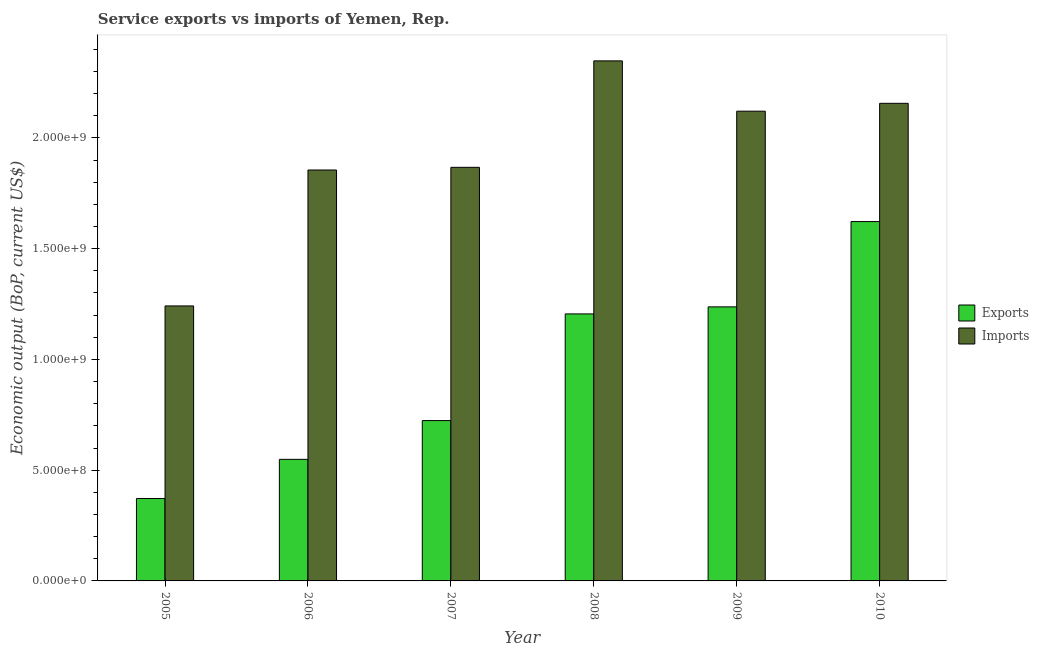How many different coloured bars are there?
Provide a short and direct response. 2. How many groups of bars are there?
Give a very brief answer. 6. What is the label of the 6th group of bars from the left?
Give a very brief answer. 2010. What is the amount of service imports in 2010?
Keep it short and to the point. 2.16e+09. Across all years, what is the maximum amount of service exports?
Make the answer very short. 1.62e+09. Across all years, what is the minimum amount of service imports?
Your response must be concise. 1.24e+09. In which year was the amount of service exports maximum?
Give a very brief answer. 2010. What is the total amount of service imports in the graph?
Give a very brief answer. 1.16e+1. What is the difference between the amount of service imports in 2005 and that in 2006?
Make the answer very short. -6.14e+08. What is the difference between the amount of service exports in 2005 and the amount of service imports in 2007?
Keep it short and to the point. -3.52e+08. What is the average amount of service imports per year?
Offer a very short reply. 1.93e+09. What is the ratio of the amount of service imports in 2005 to that in 2006?
Ensure brevity in your answer.  0.67. Is the amount of service exports in 2005 less than that in 2009?
Provide a short and direct response. Yes. What is the difference between the highest and the second highest amount of service exports?
Give a very brief answer. 3.85e+08. What is the difference between the highest and the lowest amount of service exports?
Keep it short and to the point. 1.25e+09. What does the 1st bar from the left in 2005 represents?
Give a very brief answer. Exports. What does the 1st bar from the right in 2006 represents?
Your response must be concise. Imports. How many years are there in the graph?
Your answer should be very brief. 6. What is the difference between two consecutive major ticks on the Y-axis?
Keep it short and to the point. 5.00e+08. Does the graph contain grids?
Give a very brief answer. No. How many legend labels are there?
Keep it short and to the point. 2. How are the legend labels stacked?
Make the answer very short. Vertical. What is the title of the graph?
Offer a terse response. Service exports vs imports of Yemen, Rep. Does "Foreign Liabilities" appear as one of the legend labels in the graph?
Ensure brevity in your answer.  No. What is the label or title of the X-axis?
Your answer should be very brief. Year. What is the label or title of the Y-axis?
Keep it short and to the point. Economic output (BoP, current US$). What is the Economic output (BoP, current US$) in Exports in 2005?
Provide a short and direct response. 3.72e+08. What is the Economic output (BoP, current US$) of Imports in 2005?
Keep it short and to the point. 1.24e+09. What is the Economic output (BoP, current US$) of Exports in 2006?
Your answer should be very brief. 5.49e+08. What is the Economic output (BoP, current US$) in Imports in 2006?
Provide a short and direct response. 1.86e+09. What is the Economic output (BoP, current US$) of Exports in 2007?
Give a very brief answer. 7.24e+08. What is the Economic output (BoP, current US$) of Imports in 2007?
Ensure brevity in your answer.  1.87e+09. What is the Economic output (BoP, current US$) of Exports in 2008?
Keep it short and to the point. 1.21e+09. What is the Economic output (BoP, current US$) of Imports in 2008?
Provide a succinct answer. 2.35e+09. What is the Economic output (BoP, current US$) in Exports in 2009?
Your answer should be compact. 1.24e+09. What is the Economic output (BoP, current US$) in Imports in 2009?
Offer a terse response. 2.12e+09. What is the Economic output (BoP, current US$) of Exports in 2010?
Your response must be concise. 1.62e+09. What is the Economic output (BoP, current US$) in Imports in 2010?
Keep it short and to the point. 2.16e+09. Across all years, what is the maximum Economic output (BoP, current US$) in Exports?
Ensure brevity in your answer.  1.62e+09. Across all years, what is the maximum Economic output (BoP, current US$) of Imports?
Ensure brevity in your answer.  2.35e+09. Across all years, what is the minimum Economic output (BoP, current US$) of Exports?
Offer a terse response. 3.72e+08. Across all years, what is the minimum Economic output (BoP, current US$) in Imports?
Provide a succinct answer. 1.24e+09. What is the total Economic output (BoP, current US$) in Exports in the graph?
Offer a terse response. 5.71e+09. What is the total Economic output (BoP, current US$) in Imports in the graph?
Your response must be concise. 1.16e+1. What is the difference between the Economic output (BoP, current US$) in Exports in 2005 and that in 2006?
Your response must be concise. -1.77e+08. What is the difference between the Economic output (BoP, current US$) of Imports in 2005 and that in 2006?
Offer a very short reply. -6.14e+08. What is the difference between the Economic output (BoP, current US$) in Exports in 2005 and that in 2007?
Offer a terse response. -3.52e+08. What is the difference between the Economic output (BoP, current US$) in Imports in 2005 and that in 2007?
Your answer should be compact. -6.26e+08. What is the difference between the Economic output (BoP, current US$) of Exports in 2005 and that in 2008?
Give a very brief answer. -8.33e+08. What is the difference between the Economic output (BoP, current US$) of Imports in 2005 and that in 2008?
Offer a very short reply. -1.11e+09. What is the difference between the Economic output (BoP, current US$) of Exports in 2005 and that in 2009?
Ensure brevity in your answer.  -8.65e+08. What is the difference between the Economic output (BoP, current US$) of Imports in 2005 and that in 2009?
Provide a short and direct response. -8.79e+08. What is the difference between the Economic output (BoP, current US$) in Exports in 2005 and that in 2010?
Keep it short and to the point. -1.25e+09. What is the difference between the Economic output (BoP, current US$) of Imports in 2005 and that in 2010?
Your answer should be compact. -9.15e+08. What is the difference between the Economic output (BoP, current US$) of Exports in 2006 and that in 2007?
Your response must be concise. -1.75e+08. What is the difference between the Economic output (BoP, current US$) in Imports in 2006 and that in 2007?
Offer a very short reply. -1.21e+07. What is the difference between the Economic output (BoP, current US$) in Exports in 2006 and that in 2008?
Ensure brevity in your answer.  -6.57e+08. What is the difference between the Economic output (BoP, current US$) in Imports in 2006 and that in 2008?
Your response must be concise. -4.93e+08. What is the difference between the Economic output (BoP, current US$) of Exports in 2006 and that in 2009?
Provide a succinct answer. -6.88e+08. What is the difference between the Economic output (BoP, current US$) of Imports in 2006 and that in 2009?
Your answer should be very brief. -2.66e+08. What is the difference between the Economic output (BoP, current US$) in Exports in 2006 and that in 2010?
Provide a succinct answer. -1.07e+09. What is the difference between the Economic output (BoP, current US$) of Imports in 2006 and that in 2010?
Your answer should be compact. -3.01e+08. What is the difference between the Economic output (BoP, current US$) of Exports in 2007 and that in 2008?
Your answer should be very brief. -4.82e+08. What is the difference between the Economic output (BoP, current US$) in Imports in 2007 and that in 2008?
Provide a succinct answer. -4.81e+08. What is the difference between the Economic output (BoP, current US$) in Exports in 2007 and that in 2009?
Offer a very short reply. -5.13e+08. What is the difference between the Economic output (BoP, current US$) of Imports in 2007 and that in 2009?
Ensure brevity in your answer.  -2.53e+08. What is the difference between the Economic output (BoP, current US$) of Exports in 2007 and that in 2010?
Your response must be concise. -8.98e+08. What is the difference between the Economic output (BoP, current US$) of Imports in 2007 and that in 2010?
Offer a terse response. -2.89e+08. What is the difference between the Economic output (BoP, current US$) of Exports in 2008 and that in 2009?
Give a very brief answer. -3.18e+07. What is the difference between the Economic output (BoP, current US$) of Imports in 2008 and that in 2009?
Provide a short and direct response. 2.27e+08. What is the difference between the Economic output (BoP, current US$) in Exports in 2008 and that in 2010?
Provide a short and direct response. -4.17e+08. What is the difference between the Economic output (BoP, current US$) in Imports in 2008 and that in 2010?
Provide a succinct answer. 1.92e+08. What is the difference between the Economic output (BoP, current US$) in Exports in 2009 and that in 2010?
Provide a succinct answer. -3.85e+08. What is the difference between the Economic output (BoP, current US$) in Imports in 2009 and that in 2010?
Your response must be concise. -3.55e+07. What is the difference between the Economic output (BoP, current US$) of Exports in 2005 and the Economic output (BoP, current US$) of Imports in 2006?
Provide a succinct answer. -1.48e+09. What is the difference between the Economic output (BoP, current US$) in Exports in 2005 and the Economic output (BoP, current US$) in Imports in 2007?
Give a very brief answer. -1.50e+09. What is the difference between the Economic output (BoP, current US$) in Exports in 2005 and the Economic output (BoP, current US$) in Imports in 2008?
Provide a succinct answer. -1.98e+09. What is the difference between the Economic output (BoP, current US$) of Exports in 2005 and the Economic output (BoP, current US$) of Imports in 2009?
Make the answer very short. -1.75e+09. What is the difference between the Economic output (BoP, current US$) in Exports in 2005 and the Economic output (BoP, current US$) in Imports in 2010?
Your response must be concise. -1.78e+09. What is the difference between the Economic output (BoP, current US$) in Exports in 2006 and the Economic output (BoP, current US$) in Imports in 2007?
Your answer should be very brief. -1.32e+09. What is the difference between the Economic output (BoP, current US$) of Exports in 2006 and the Economic output (BoP, current US$) of Imports in 2008?
Your response must be concise. -1.80e+09. What is the difference between the Economic output (BoP, current US$) of Exports in 2006 and the Economic output (BoP, current US$) of Imports in 2009?
Ensure brevity in your answer.  -1.57e+09. What is the difference between the Economic output (BoP, current US$) of Exports in 2006 and the Economic output (BoP, current US$) of Imports in 2010?
Provide a succinct answer. -1.61e+09. What is the difference between the Economic output (BoP, current US$) in Exports in 2007 and the Economic output (BoP, current US$) in Imports in 2008?
Keep it short and to the point. -1.62e+09. What is the difference between the Economic output (BoP, current US$) in Exports in 2007 and the Economic output (BoP, current US$) in Imports in 2009?
Keep it short and to the point. -1.40e+09. What is the difference between the Economic output (BoP, current US$) in Exports in 2007 and the Economic output (BoP, current US$) in Imports in 2010?
Offer a terse response. -1.43e+09. What is the difference between the Economic output (BoP, current US$) in Exports in 2008 and the Economic output (BoP, current US$) in Imports in 2009?
Provide a succinct answer. -9.15e+08. What is the difference between the Economic output (BoP, current US$) of Exports in 2008 and the Economic output (BoP, current US$) of Imports in 2010?
Your answer should be very brief. -9.51e+08. What is the difference between the Economic output (BoP, current US$) of Exports in 2009 and the Economic output (BoP, current US$) of Imports in 2010?
Your response must be concise. -9.19e+08. What is the average Economic output (BoP, current US$) in Exports per year?
Make the answer very short. 9.52e+08. What is the average Economic output (BoP, current US$) of Imports per year?
Make the answer very short. 1.93e+09. In the year 2005, what is the difference between the Economic output (BoP, current US$) of Exports and Economic output (BoP, current US$) of Imports?
Ensure brevity in your answer.  -8.69e+08. In the year 2006, what is the difference between the Economic output (BoP, current US$) in Exports and Economic output (BoP, current US$) in Imports?
Your response must be concise. -1.31e+09. In the year 2007, what is the difference between the Economic output (BoP, current US$) in Exports and Economic output (BoP, current US$) in Imports?
Provide a succinct answer. -1.14e+09. In the year 2008, what is the difference between the Economic output (BoP, current US$) of Exports and Economic output (BoP, current US$) of Imports?
Your response must be concise. -1.14e+09. In the year 2009, what is the difference between the Economic output (BoP, current US$) of Exports and Economic output (BoP, current US$) of Imports?
Give a very brief answer. -8.83e+08. In the year 2010, what is the difference between the Economic output (BoP, current US$) of Exports and Economic output (BoP, current US$) of Imports?
Your response must be concise. -5.34e+08. What is the ratio of the Economic output (BoP, current US$) in Exports in 2005 to that in 2006?
Offer a very short reply. 0.68. What is the ratio of the Economic output (BoP, current US$) in Imports in 2005 to that in 2006?
Keep it short and to the point. 0.67. What is the ratio of the Economic output (BoP, current US$) of Exports in 2005 to that in 2007?
Provide a succinct answer. 0.51. What is the ratio of the Economic output (BoP, current US$) of Imports in 2005 to that in 2007?
Provide a short and direct response. 0.66. What is the ratio of the Economic output (BoP, current US$) of Exports in 2005 to that in 2008?
Offer a very short reply. 0.31. What is the ratio of the Economic output (BoP, current US$) of Imports in 2005 to that in 2008?
Make the answer very short. 0.53. What is the ratio of the Economic output (BoP, current US$) of Exports in 2005 to that in 2009?
Give a very brief answer. 0.3. What is the ratio of the Economic output (BoP, current US$) in Imports in 2005 to that in 2009?
Provide a succinct answer. 0.59. What is the ratio of the Economic output (BoP, current US$) of Exports in 2005 to that in 2010?
Offer a terse response. 0.23. What is the ratio of the Economic output (BoP, current US$) of Imports in 2005 to that in 2010?
Your response must be concise. 0.58. What is the ratio of the Economic output (BoP, current US$) in Exports in 2006 to that in 2007?
Your answer should be very brief. 0.76. What is the ratio of the Economic output (BoP, current US$) of Exports in 2006 to that in 2008?
Keep it short and to the point. 0.46. What is the ratio of the Economic output (BoP, current US$) of Imports in 2006 to that in 2008?
Offer a very short reply. 0.79. What is the ratio of the Economic output (BoP, current US$) of Exports in 2006 to that in 2009?
Ensure brevity in your answer.  0.44. What is the ratio of the Economic output (BoP, current US$) in Imports in 2006 to that in 2009?
Provide a succinct answer. 0.87. What is the ratio of the Economic output (BoP, current US$) of Exports in 2006 to that in 2010?
Ensure brevity in your answer.  0.34. What is the ratio of the Economic output (BoP, current US$) in Imports in 2006 to that in 2010?
Provide a short and direct response. 0.86. What is the ratio of the Economic output (BoP, current US$) in Exports in 2007 to that in 2008?
Keep it short and to the point. 0.6. What is the ratio of the Economic output (BoP, current US$) of Imports in 2007 to that in 2008?
Your answer should be very brief. 0.8. What is the ratio of the Economic output (BoP, current US$) of Exports in 2007 to that in 2009?
Provide a short and direct response. 0.59. What is the ratio of the Economic output (BoP, current US$) of Imports in 2007 to that in 2009?
Give a very brief answer. 0.88. What is the ratio of the Economic output (BoP, current US$) of Exports in 2007 to that in 2010?
Your answer should be very brief. 0.45. What is the ratio of the Economic output (BoP, current US$) in Imports in 2007 to that in 2010?
Give a very brief answer. 0.87. What is the ratio of the Economic output (BoP, current US$) of Exports in 2008 to that in 2009?
Provide a short and direct response. 0.97. What is the ratio of the Economic output (BoP, current US$) in Imports in 2008 to that in 2009?
Ensure brevity in your answer.  1.11. What is the ratio of the Economic output (BoP, current US$) in Exports in 2008 to that in 2010?
Your answer should be very brief. 0.74. What is the ratio of the Economic output (BoP, current US$) in Imports in 2008 to that in 2010?
Ensure brevity in your answer.  1.09. What is the ratio of the Economic output (BoP, current US$) of Exports in 2009 to that in 2010?
Offer a very short reply. 0.76. What is the ratio of the Economic output (BoP, current US$) in Imports in 2009 to that in 2010?
Provide a short and direct response. 0.98. What is the difference between the highest and the second highest Economic output (BoP, current US$) in Exports?
Ensure brevity in your answer.  3.85e+08. What is the difference between the highest and the second highest Economic output (BoP, current US$) of Imports?
Your answer should be very brief. 1.92e+08. What is the difference between the highest and the lowest Economic output (BoP, current US$) in Exports?
Offer a very short reply. 1.25e+09. What is the difference between the highest and the lowest Economic output (BoP, current US$) of Imports?
Your answer should be compact. 1.11e+09. 